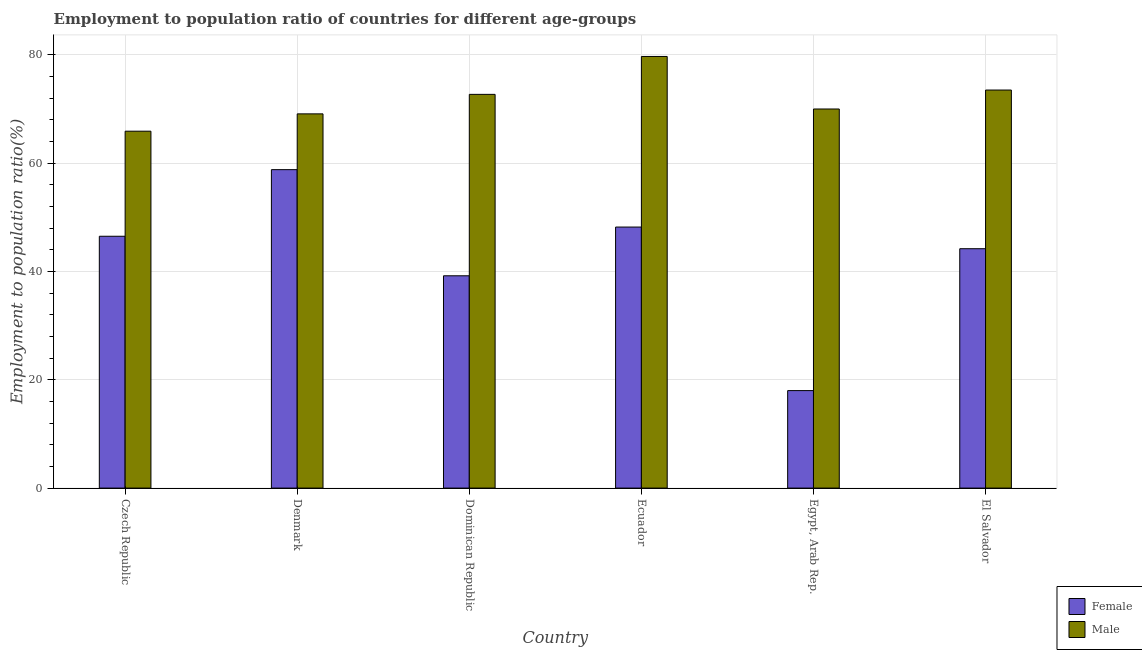How many bars are there on the 4th tick from the left?
Your response must be concise. 2. How many bars are there on the 6th tick from the right?
Provide a succinct answer. 2. What is the label of the 5th group of bars from the left?
Your answer should be compact. Egypt, Arab Rep. What is the employment to population ratio(male) in Ecuador?
Offer a terse response. 79.7. Across all countries, what is the maximum employment to population ratio(female)?
Offer a very short reply. 58.8. In which country was the employment to population ratio(male) maximum?
Keep it short and to the point. Ecuador. In which country was the employment to population ratio(female) minimum?
Give a very brief answer. Egypt, Arab Rep. What is the total employment to population ratio(male) in the graph?
Ensure brevity in your answer.  430.9. What is the difference between the employment to population ratio(female) in Denmark and that in Dominican Republic?
Offer a terse response. 19.6. What is the difference between the employment to population ratio(male) in Ecuador and the employment to population ratio(female) in El Salvador?
Your response must be concise. 35.5. What is the average employment to population ratio(male) per country?
Keep it short and to the point. 71.82. What is the difference between the employment to population ratio(male) and employment to population ratio(female) in El Salvador?
Ensure brevity in your answer.  29.3. What is the ratio of the employment to population ratio(female) in Czech Republic to that in Ecuador?
Offer a terse response. 0.96. Is the difference between the employment to population ratio(male) in Egypt, Arab Rep. and El Salvador greater than the difference between the employment to population ratio(female) in Egypt, Arab Rep. and El Salvador?
Your response must be concise. Yes. What is the difference between the highest and the second highest employment to population ratio(male)?
Make the answer very short. 6.2. What is the difference between the highest and the lowest employment to population ratio(female)?
Keep it short and to the point. 40.8. In how many countries, is the employment to population ratio(female) greater than the average employment to population ratio(female) taken over all countries?
Make the answer very short. 4. What does the 2nd bar from the left in Dominican Republic represents?
Make the answer very short. Male. What does the 1st bar from the right in Egypt, Arab Rep. represents?
Make the answer very short. Male. How many bars are there?
Provide a succinct answer. 12. Are all the bars in the graph horizontal?
Ensure brevity in your answer.  No. How many countries are there in the graph?
Your answer should be compact. 6. Are the values on the major ticks of Y-axis written in scientific E-notation?
Your answer should be compact. No. Does the graph contain any zero values?
Your answer should be compact. No. Does the graph contain grids?
Provide a short and direct response. Yes. Where does the legend appear in the graph?
Make the answer very short. Bottom right. How are the legend labels stacked?
Your answer should be very brief. Vertical. What is the title of the graph?
Keep it short and to the point. Employment to population ratio of countries for different age-groups. Does "Non-pregnant women" appear as one of the legend labels in the graph?
Your answer should be compact. No. What is the label or title of the X-axis?
Your answer should be very brief. Country. What is the Employment to population ratio(%) in Female in Czech Republic?
Offer a terse response. 46.5. What is the Employment to population ratio(%) in Male in Czech Republic?
Your response must be concise. 65.9. What is the Employment to population ratio(%) in Female in Denmark?
Make the answer very short. 58.8. What is the Employment to population ratio(%) in Male in Denmark?
Provide a succinct answer. 69.1. What is the Employment to population ratio(%) in Female in Dominican Republic?
Your answer should be very brief. 39.2. What is the Employment to population ratio(%) of Male in Dominican Republic?
Provide a short and direct response. 72.7. What is the Employment to population ratio(%) of Female in Ecuador?
Provide a short and direct response. 48.2. What is the Employment to population ratio(%) of Male in Ecuador?
Provide a succinct answer. 79.7. What is the Employment to population ratio(%) in Female in Egypt, Arab Rep.?
Offer a very short reply. 18. What is the Employment to population ratio(%) of Male in Egypt, Arab Rep.?
Provide a short and direct response. 70. What is the Employment to population ratio(%) of Female in El Salvador?
Offer a very short reply. 44.2. What is the Employment to population ratio(%) of Male in El Salvador?
Offer a terse response. 73.5. Across all countries, what is the maximum Employment to population ratio(%) of Female?
Ensure brevity in your answer.  58.8. Across all countries, what is the maximum Employment to population ratio(%) of Male?
Ensure brevity in your answer.  79.7. Across all countries, what is the minimum Employment to population ratio(%) of Male?
Ensure brevity in your answer.  65.9. What is the total Employment to population ratio(%) of Female in the graph?
Offer a very short reply. 254.9. What is the total Employment to population ratio(%) in Male in the graph?
Your response must be concise. 430.9. What is the difference between the Employment to population ratio(%) of Female in Czech Republic and that in Dominican Republic?
Offer a terse response. 7.3. What is the difference between the Employment to population ratio(%) of Male in Czech Republic and that in Egypt, Arab Rep.?
Ensure brevity in your answer.  -4.1. What is the difference between the Employment to population ratio(%) of Female in Denmark and that in Dominican Republic?
Your response must be concise. 19.6. What is the difference between the Employment to population ratio(%) of Female in Denmark and that in Ecuador?
Provide a short and direct response. 10.6. What is the difference between the Employment to population ratio(%) in Female in Denmark and that in Egypt, Arab Rep.?
Your answer should be very brief. 40.8. What is the difference between the Employment to population ratio(%) of Female in Denmark and that in El Salvador?
Provide a short and direct response. 14.6. What is the difference between the Employment to population ratio(%) in Male in Denmark and that in El Salvador?
Make the answer very short. -4.4. What is the difference between the Employment to population ratio(%) in Female in Dominican Republic and that in Ecuador?
Your answer should be compact. -9. What is the difference between the Employment to population ratio(%) in Male in Dominican Republic and that in Ecuador?
Keep it short and to the point. -7. What is the difference between the Employment to population ratio(%) in Female in Dominican Republic and that in Egypt, Arab Rep.?
Give a very brief answer. 21.2. What is the difference between the Employment to population ratio(%) of Female in Dominican Republic and that in El Salvador?
Your response must be concise. -5. What is the difference between the Employment to population ratio(%) of Male in Dominican Republic and that in El Salvador?
Your response must be concise. -0.8. What is the difference between the Employment to population ratio(%) of Female in Ecuador and that in Egypt, Arab Rep.?
Give a very brief answer. 30.2. What is the difference between the Employment to population ratio(%) in Male in Ecuador and that in Egypt, Arab Rep.?
Your answer should be very brief. 9.7. What is the difference between the Employment to population ratio(%) in Female in Ecuador and that in El Salvador?
Provide a short and direct response. 4. What is the difference between the Employment to population ratio(%) of Female in Egypt, Arab Rep. and that in El Salvador?
Your answer should be compact. -26.2. What is the difference between the Employment to population ratio(%) of Male in Egypt, Arab Rep. and that in El Salvador?
Provide a succinct answer. -3.5. What is the difference between the Employment to population ratio(%) in Female in Czech Republic and the Employment to population ratio(%) in Male in Denmark?
Offer a very short reply. -22.6. What is the difference between the Employment to population ratio(%) of Female in Czech Republic and the Employment to population ratio(%) of Male in Dominican Republic?
Offer a terse response. -26.2. What is the difference between the Employment to population ratio(%) in Female in Czech Republic and the Employment to population ratio(%) in Male in Ecuador?
Make the answer very short. -33.2. What is the difference between the Employment to population ratio(%) in Female in Czech Republic and the Employment to population ratio(%) in Male in Egypt, Arab Rep.?
Your response must be concise. -23.5. What is the difference between the Employment to population ratio(%) of Female in Czech Republic and the Employment to population ratio(%) of Male in El Salvador?
Keep it short and to the point. -27. What is the difference between the Employment to population ratio(%) of Female in Denmark and the Employment to population ratio(%) of Male in Dominican Republic?
Give a very brief answer. -13.9. What is the difference between the Employment to population ratio(%) in Female in Denmark and the Employment to population ratio(%) in Male in Ecuador?
Your response must be concise. -20.9. What is the difference between the Employment to population ratio(%) in Female in Denmark and the Employment to population ratio(%) in Male in El Salvador?
Your answer should be very brief. -14.7. What is the difference between the Employment to population ratio(%) in Female in Dominican Republic and the Employment to population ratio(%) in Male in Ecuador?
Keep it short and to the point. -40.5. What is the difference between the Employment to population ratio(%) of Female in Dominican Republic and the Employment to population ratio(%) of Male in Egypt, Arab Rep.?
Ensure brevity in your answer.  -30.8. What is the difference between the Employment to population ratio(%) of Female in Dominican Republic and the Employment to population ratio(%) of Male in El Salvador?
Offer a very short reply. -34.3. What is the difference between the Employment to population ratio(%) in Female in Ecuador and the Employment to population ratio(%) in Male in Egypt, Arab Rep.?
Your answer should be compact. -21.8. What is the difference between the Employment to population ratio(%) in Female in Ecuador and the Employment to population ratio(%) in Male in El Salvador?
Offer a terse response. -25.3. What is the difference between the Employment to population ratio(%) of Female in Egypt, Arab Rep. and the Employment to population ratio(%) of Male in El Salvador?
Ensure brevity in your answer.  -55.5. What is the average Employment to population ratio(%) of Female per country?
Keep it short and to the point. 42.48. What is the average Employment to population ratio(%) in Male per country?
Give a very brief answer. 71.82. What is the difference between the Employment to population ratio(%) of Female and Employment to population ratio(%) of Male in Czech Republic?
Keep it short and to the point. -19.4. What is the difference between the Employment to population ratio(%) in Female and Employment to population ratio(%) in Male in Dominican Republic?
Make the answer very short. -33.5. What is the difference between the Employment to population ratio(%) of Female and Employment to population ratio(%) of Male in Ecuador?
Give a very brief answer. -31.5. What is the difference between the Employment to population ratio(%) in Female and Employment to population ratio(%) in Male in Egypt, Arab Rep.?
Your answer should be compact. -52. What is the difference between the Employment to population ratio(%) of Female and Employment to population ratio(%) of Male in El Salvador?
Your response must be concise. -29.3. What is the ratio of the Employment to population ratio(%) in Female in Czech Republic to that in Denmark?
Offer a terse response. 0.79. What is the ratio of the Employment to population ratio(%) of Male in Czech Republic to that in Denmark?
Your response must be concise. 0.95. What is the ratio of the Employment to population ratio(%) in Female in Czech Republic to that in Dominican Republic?
Provide a short and direct response. 1.19. What is the ratio of the Employment to population ratio(%) of Male in Czech Republic to that in Dominican Republic?
Ensure brevity in your answer.  0.91. What is the ratio of the Employment to population ratio(%) in Female in Czech Republic to that in Ecuador?
Your response must be concise. 0.96. What is the ratio of the Employment to population ratio(%) in Male in Czech Republic to that in Ecuador?
Your answer should be very brief. 0.83. What is the ratio of the Employment to population ratio(%) in Female in Czech Republic to that in Egypt, Arab Rep.?
Ensure brevity in your answer.  2.58. What is the ratio of the Employment to population ratio(%) in Male in Czech Republic to that in Egypt, Arab Rep.?
Ensure brevity in your answer.  0.94. What is the ratio of the Employment to population ratio(%) in Female in Czech Republic to that in El Salvador?
Your answer should be very brief. 1.05. What is the ratio of the Employment to population ratio(%) of Male in Czech Republic to that in El Salvador?
Provide a succinct answer. 0.9. What is the ratio of the Employment to population ratio(%) in Male in Denmark to that in Dominican Republic?
Provide a succinct answer. 0.95. What is the ratio of the Employment to population ratio(%) in Female in Denmark to that in Ecuador?
Ensure brevity in your answer.  1.22. What is the ratio of the Employment to population ratio(%) in Male in Denmark to that in Ecuador?
Provide a succinct answer. 0.87. What is the ratio of the Employment to population ratio(%) in Female in Denmark to that in Egypt, Arab Rep.?
Your answer should be very brief. 3.27. What is the ratio of the Employment to population ratio(%) in Male in Denmark to that in Egypt, Arab Rep.?
Keep it short and to the point. 0.99. What is the ratio of the Employment to population ratio(%) of Female in Denmark to that in El Salvador?
Keep it short and to the point. 1.33. What is the ratio of the Employment to population ratio(%) of Male in Denmark to that in El Salvador?
Give a very brief answer. 0.94. What is the ratio of the Employment to population ratio(%) in Female in Dominican Republic to that in Ecuador?
Keep it short and to the point. 0.81. What is the ratio of the Employment to population ratio(%) in Male in Dominican Republic to that in Ecuador?
Your answer should be compact. 0.91. What is the ratio of the Employment to population ratio(%) of Female in Dominican Republic to that in Egypt, Arab Rep.?
Offer a terse response. 2.18. What is the ratio of the Employment to population ratio(%) of Male in Dominican Republic to that in Egypt, Arab Rep.?
Your answer should be very brief. 1.04. What is the ratio of the Employment to population ratio(%) in Female in Dominican Republic to that in El Salvador?
Your response must be concise. 0.89. What is the ratio of the Employment to population ratio(%) in Female in Ecuador to that in Egypt, Arab Rep.?
Ensure brevity in your answer.  2.68. What is the ratio of the Employment to population ratio(%) in Male in Ecuador to that in Egypt, Arab Rep.?
Your response must be concise. 1.14. What is the ratio of the Employment to population ratio(%) of Female in Ecuador to that in El Salvador?
Your answer should be compact. 1.09. What is the ratio of the Employment to population ratio(%) of Male in Ecuador to that in El Salvador?
Ensure brevity in your answer.  1.08. What is the ratio of the Employment to population ratio(%) in Female in Egypt, Arab Rep. to that in El Salvador?
Give a very brief answer. 0.41. What is the ratio of the Employment to population ratio(%) of Male in Egypt, Arab Rep. to that in El Salvador?
Keep it short and to the point. 0.95. What is the difference between the highest and the lowest Employment to population ratio(%) of Female?
Your answer should be compact. 40.8. 